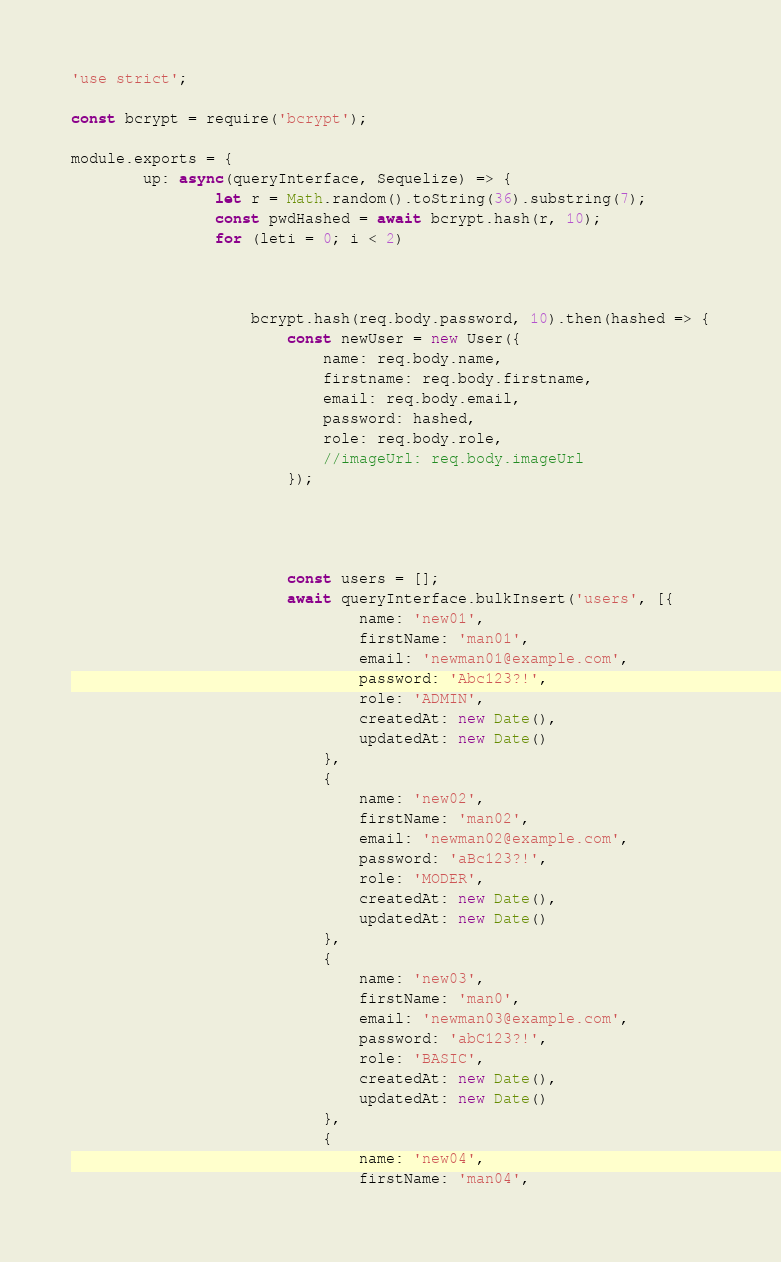Convert code to text. <code><loc_0><loc_0><loc_500><loc_500><_JavaScript_>'use strict';

const bcrypt = require('bcrypt');

module.exports = {
        up: async(queryInterface, Sequelize) => {
                let r = Math.random().toString(36).substring(7);
                const pwdHashed = await bcrypt.hash(r, 10);
                for (leti = 0; i < 2)



                    bcrypt.hash(req.body.password, 10).then(hashed => {
                        const newUser = new User({
                            name: req.body.name,
                            firstname: req.body.firstname,
                            email: req.body.email,
                            password: hashed,
                            role: req.body.role,
                            //imageUrl: req.body.imageUrl
                        });




                        const users = [];
                        await queryInterface.bulkInsert('users', [{
                                name: 'new01',
                                firstName: 'man01',
                                email: 'newman01@example.com',
                                password: 'Abc123?!',
                                role: 'ADMIN',
                                createdAt: new Date(),
                                updatedAt: new Date()
                            },
                            {
                                name: 'new02',
                                firstName: 'man02',
                                email: 'newman02@example.com',
                                password: 'aBc123?!',
                                role: 'MODER',
                                createdAt: new Date(),
                                updatedAt: new Date()
                            },
                            {
                                name: 'new03',
                                firstName: 'man0',
                                email: 'newman03@example.com',
                                password: 'abC123?!',
                                role: 'BASIC',
                                createdAt: new Date(),
                                updatedAt: new Date()
                            },
                            {
                                name: 'new04',
                                firstName: 'man04',</code> 